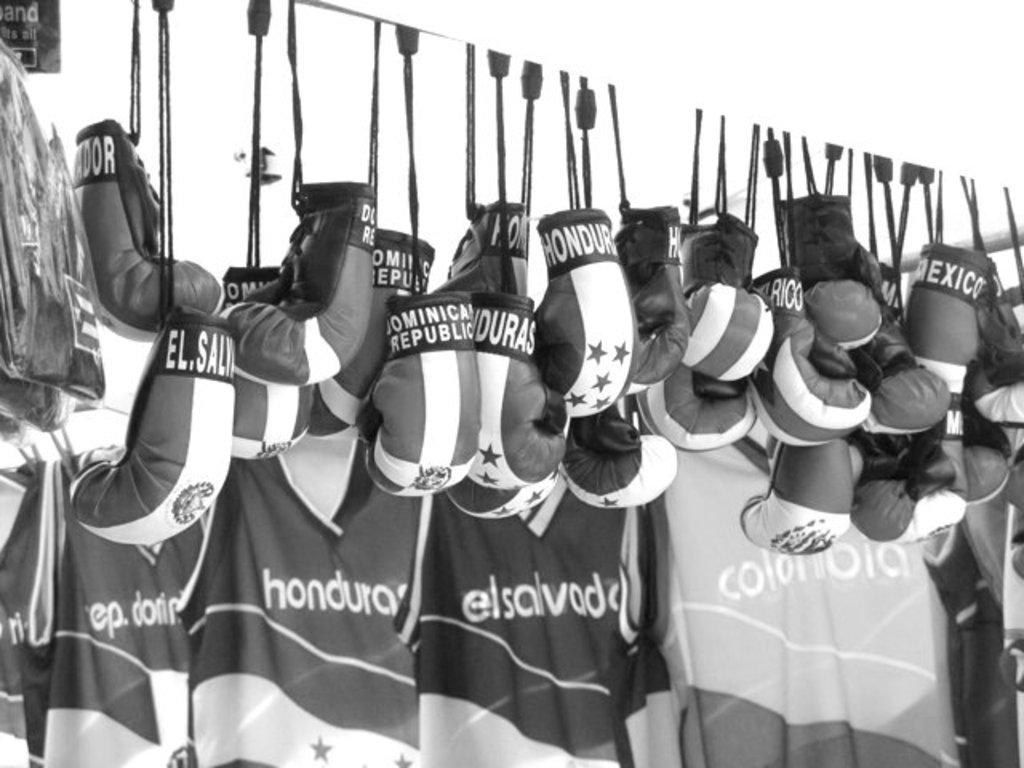<image>
Describe the image concisely. Boxing attire from Honduras, El Salvador, and Colombia hang on the wall. 